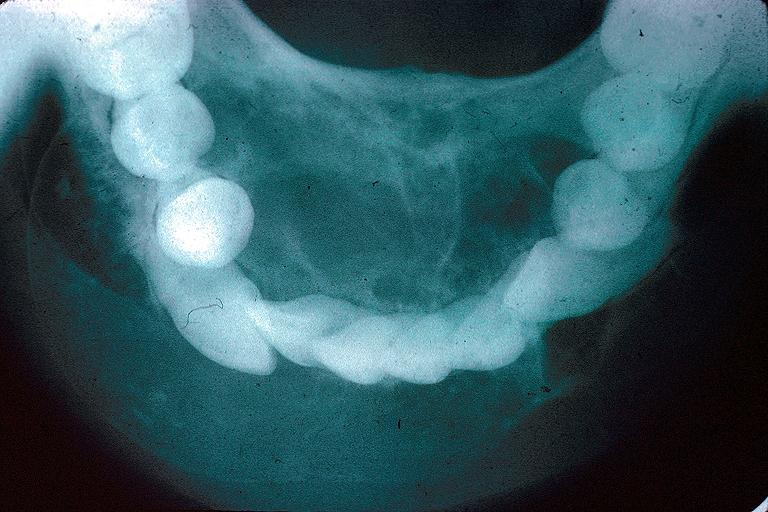does eosinophilic adenoma show odontogenic myxoma?
Answer the question using a single word or phrase. No 